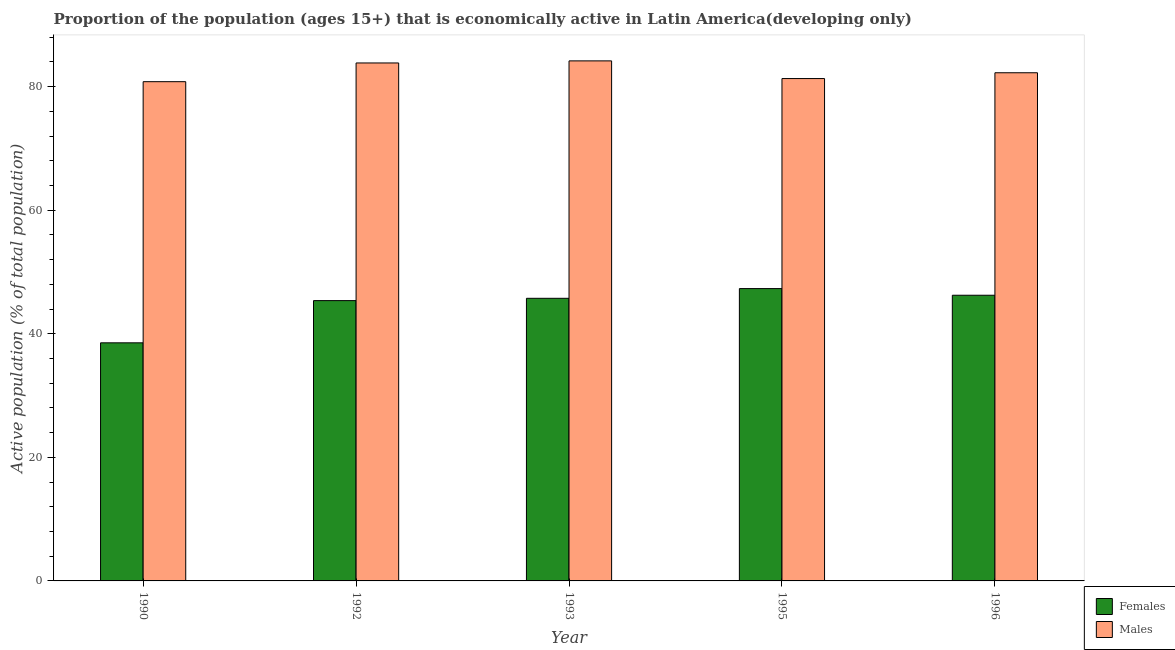How many different coloured bars are there?
Give a very brief answer. 2. How many groups of bars are there?
Provide a succinct answer. 5. How many bars are there on the 2nd tick from the left?
Keep it short and to the point. 2. What is the label of the 2nd group of bars from the left?
Offer a very short reply. 1992. In how many cases, is the number of bars for a given year not equal to the number of legend labels?
Offer a terse response. 0. What is the percentage of economically active male population in 1990?
Provide a short and direct response. 80.8. Across all years, what is the maximum percentage of economically active male population?
Offer a very short reply. 84.17. Across all years, what is the minimum percentage of economically active male population?
Provide a short and direct response. 80.8. In which year was the percentage of economically active female population minimum?
Make the answer very short. 1990. What is the total percentage of economically active male population in the graph?
Give a very brief answer. 412.35. What is the difference between the percentage of economically active female population in 1992 and that in 1995?
Your response must be concise. -1.95. What is the difference between the percentage of economically active male population in 1990 and the percentage of economically active female population in 1992?
Offer a very short reply. -3.03. What is the average percentage of economically active female population per year?
Keep it short and to the point. 44.64. What is the ratio of the percentage of economically active female population in 1993 to that in 1995?
Make the answer very short. 0.97. What is the difference between the highest and the second highest percentage of economically active male population?
Your answer should be compact. 0.34. What is the difference between the highest and the lowest percentage of economically active male population?
Provide a succinct answer. 3.37. What does the 1st bar from the left in 1996 represents?
Your answer should be compact. Females. What does the 2nd bar from the right in 1992 represents?
Ensure brevity in your answer.  Females. Are all the bars in the graph horizontal?
Offer a terse response. No. What is the difference between two consecutive major ticks on the Y-axis?
Your answer should be compact. 20. Are the values on the major ticks of Y-axis written in scientific E-notation?
Offer a very short reply. No. Does the graph contain grids?
Provide a succinct answer. No. Where does the legend appear in the graph?
Give a very brief answer. Bottom right. How many legend labels are there?
Your answer should be compact. 2. How are the legend labels stacked?
Give a very brief answer. Vertical. What is the title of the graph?
Provide a succinct answer. Proportion of the population (ages 15+) that is economically active in Latin America(developing only). What is the label or title of the Y-axis?
Keep it short and to the point. Active population (% of total population). What is the Active population (% of total population) in Females in 1990?
Ensure brevity in your answer.  38.53. What is the Active population (% of total population) in Males in 1990?
Provide a short and direct response. 80.8. What is the Active population (% of total population) in Females in 1992?
Offer a very short reply. 45.37. What is the Active population (% of total population) in Males in 1992?
Ensure brevity in your answer.  83.83. What is the Active population (% of total population) in Females in 1993?
Give a very brief answer. 45.74. What is the Active population (% of total population) in Males in 1993?
Ensure brevity in your answer.  84.17. What is the Active population (% of total population) of Females in 1995?
Provide a short and direct response. 47.31. What is the Active population (% of total population) of Males in 1995?
Offer a very short reply. 81.31. What is the Active population (% of total population) of Females in 1996?
Make the answer very short. 46.24. What is the Active population (% of total population) in Males in 1996?
Provide a succinct answer. 82.25. Across all years, what is the maximum Active population (% of total population) of Females?
Your answer should be very brief. 47.31. Across all years, what is the maximum Active population (% of total population) in Males?
Keep it short and to the point. 84.17. Across all years, what is the minimum Active population (% of total population) of Females?
Offer a terse response. 38.53. Across all years, what is the minimum Active population (% of total population) in Males?
Provide a short and direct response. 80.8. What is the total Active population (% of total population) of Females in the graph?
Make the answer very short. 223.19. What is the total Active population (% of total population) in Males in the graph?
Provide a short and direct response. 412.35. What is the difference between the Active population (% of total population) of Females in 1990 and that in 1992?
Your answer should be very brief. -6.83. What is the difference between the Active population (% of total population) in Males in 1990 and that in 1992?
Your answer should be compact. -3.03. What is the difference between the Active population (% of total population) in Females in 1990 and that in 1993?
Give a very brief answer. -7.21. What is the difference between the Active population (% of total population) of Males in 1990 and that in 1993?
Provide a short and direct response. -3.37. What is the difference between the Active population (% of total population) of Females in 1990 and that in 1995?
Your answer should be compact. -8.78. What is the difference between the Active population (% of total population) of Males in 1990 and that in 1995?
Your response must be concise. -0.51. What is the difference between the Active population (% of total population) in Females in 1990 and that in 1996?
Your response must be concise. -7.7. What is the difference between the Active population (% of total population) of Males in 1990 and that in 1996?
Ensure brevity in your answer.  -1.45. What is the difference between the Active population (% of total population) in Females in 1992 and that in 1993?
Ensure brevity in your answer.  -0.37. What is the difference between the Active population (% of total population) in Males in 1992 and that in 1993?
Offer a terse response. -0.34. What is the difference between the Active population (% of total population) in Females in 1992 and that in 1995?
Offer a very short reply. -1.95. What is the difference between the Active population (% of total population) of Males in 1992 and that in 1995?
Keep it short and to the point. 2.53. What is the difference between the Active population (% of total population) in Females in 1992 and that in 1996?
Your response must be concise. -0.87. What is the difference between the Active population (% of total population) of Males in 1992 and that in 1996?
Provide a succinct answer. 1.59. What is the difference between the Active population (% of total population) of Females in 1993 and that in 1995?
Ensure brevity in your answer.  -1.57. What is the difference between the Active population (% of total population) in Males in 1993 and that in 1995?
Offer a terse response. 2.86. What is the difference between the Active population (% of total population) in Females in 1993 and that in 1996?
Provide a short and direct response. -0.5. What is the difference between the Active population (% of total population) of Males in 1993 and that in 1996?
Your answer should be very brief. 1.92. What is the difference between the Active population (% of total population) in Females in 1995 and that in 1996?
Your answer should be very brief. 1.08. What is the difference between the Active population (% of total population) of Males in 1995 and that in 1996?
Ensure brevity in your answer.  -0.94. What is the difference between the Active population (% of total population) of Females in 1990 and the Active population (% of total population) of Males in 1992?
Your answer should be very brief. -45.3. What is the difference between the Active population (% of total population) of Females in 1990 and the Active population (% of total population) of Males in 1993?
Ensure brevity in your answer.  -45.63. What is the difference between the Active population (% of total population) of Females in 1990 and the Active population (% of total population) of Males in 1995?
Provide a succinct answer. -42.77. What is the difference between the Active population (% of total population) in Females in 1990 and the Active population (% of total population) in Males in 1996?
Keep it short and to the point. -43.71. What is the difference between the Active population (% of total population) in Females in 1992 and the Active population (% of total population) in Males in 1993?
Provide a short and direct response. -38.8. What is the difference between the Active population (% of total population) in Females in 1992 and the Active population (% of total population) in Males in 1995?
Ensure brevity in your answer.  -35.94. What is the difference between the Active population (% of total population) in Females in 1992 and the Active population (% of total population) in Males in 1996?
Offer a terse response. -36.88. What is the difference between the Active population (% of total population) of Females in 1993 and the Active population (% of total population) of Males in 1995?
Offer a very short reply. -35.57. What is the difference between the Active population (% of total population) in Females in 1993 and the Active population (% of total population) in Males in 1996?
Your answer should be very brief. -36.51. What is the difference between the Active population (% of total population) of Females in 1995 and the Active population (% of total population) of Males in 1996?
Your answer should be very brief. -34.93. What is the average Active population (% of total population) of Females per year?
Your response must be concise. 44.64. What is the average Active population (% of total population) of Males per year?
Ensure brevity in your answer.  82.47. In the year 1990, what is the difference between the Active population (% of total population) of Females and Active population (% of total population) of Males?
Your answer should be compact. -42.27. In the year 1992, what is the difference between the Active population (% of total population) in Females and Active population (% of total population) in Males?
Keep it short and to the point. -38.47. In the year 1993, what is the difference between the Active population (% of total population) of Females and Active population (% of total population) of Males?
Offer a very short reply. -38.43. In the year 1995, what is the difference between the Active population (% of total population) in Females and Active population (% of total population) in Males?
Provide a succinct answer. -33.99. In the year 1996, what is the difference between the Active population (% of total population) in Females and Active population (% of total population) in Males?
Ensure brevity in your answer.  -36.01. What is the ratio of the Active population (% of total population) in Females in 1990 to that in 1992?
Ensure brevity in your answer.  0.85. What is the ratio of the Active population (% of total population) in Males in 1990 to that in 1992?
Make the answer very short. 0.96. What is the ratio of the Active population (% of total population) in Females in 1990 to that in 1993?
Offer a very short reply. 0.84. What is the ratio of the Active population (% of total population) in Females in 1990 to that in 1995?
Ensure brevity in your answer.  0.81. What is the ratio of the Active population (% of total population) in Males in 1990 to that in 1995?
Offer a terse response. 0.99. What is the ratio of the Active population (% of total population) in Females in 1990 to that in 1996?
Give a very brief answer. 0.83. What is the ratio of the Active population (% of total population) in Males in 1990 to that in 1996?
Give a very brief answer. 0.98. What is the ratio of the Active population (% of total population) in Females in 1992 to that in 1993?
Provide a short and direct response. 0.99. What is the ratio of the Active population (% of total population) in Females in 1992 to that in 1995?
Your answer should be very brief. 0.96. What is the ratio of the Active population (% of total population) of Males in 1992 to that in 1995?
Provide a succinct answer. 1.03. What is the ratio of the Active population (% of total population) of Females in 1992 to that in 1996?
Offer a very short reply. 0.98. What is the ratio of the Active population (% of total population) of Males in 1992 to that in 1996?
Provide a succinct answer. 1.02. What is the ratio of the Active population (% of total population) of Females in 1993 to that in 1995?
Provide a succinct answer. 0.97. What is the ratio of the Active population (% of total population) in Males in 1993 to that in 1995?
Your response must be concise. 1.04. What is the ratio of the Active population (% of total population) of Females in 1993 to that in 1996?
Provide a succinct answer. 0.99. What is the ratio of the Active population (% of total population) in Males in 1993 to that in 1996?
Your answer should be very brief. 1.02. What is the ratio of the Active population (% of total population) of Females in 1995 to that in 1996?
Make the answer very short. 1.02. What is the ratio of the Active population (% of total population) of Males in 1995 to that in 1996?
Provide a succinct answer. 0.99. What is the difference between the highest and the second highest Active population (% of total population) of Females?
Offer a very short reply. 1.08. What is the difference between the highest and the second highest Active population (% of total population) of Males?
Make the answer very short. 0.34. What is the difference between the highest and the lowest Active population (% of total population) in Females?
Offer a very short reply. 8.78. What is the difference between the highest and the lowest Active population (% of total population) in Males?
Provide a succinct answer. 3.37. 